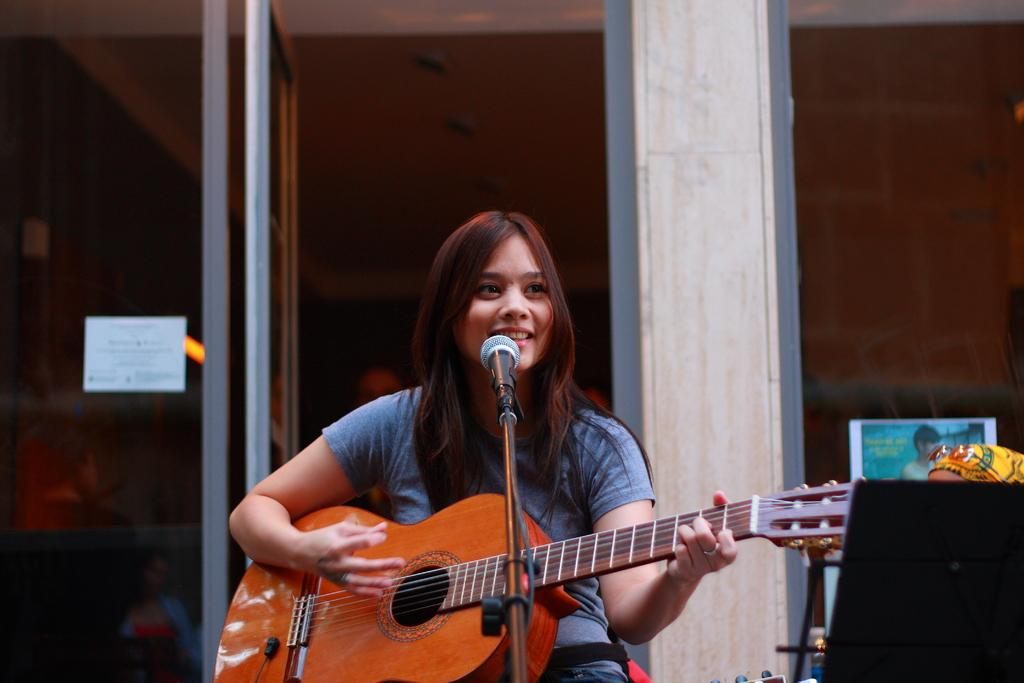Who is the main subject in the picture? There is a girl in the picture. What is the girl doing in the image? The girl is sitting and smiling, and she is playing a guitar. What can be seen in the background of the image? There is a door visible in the background. What object is in front of the girl? There is a microphone in front of the girl. What type of quiver is the girl using to hold her arrows in the image? There is no quiver or arrows present in the image; the girl is playing a guitar. How does the beggar in the image interact with the girl? There is no beggar present in the image; it only features the girl playing a guitar and a microphone in front of her. 